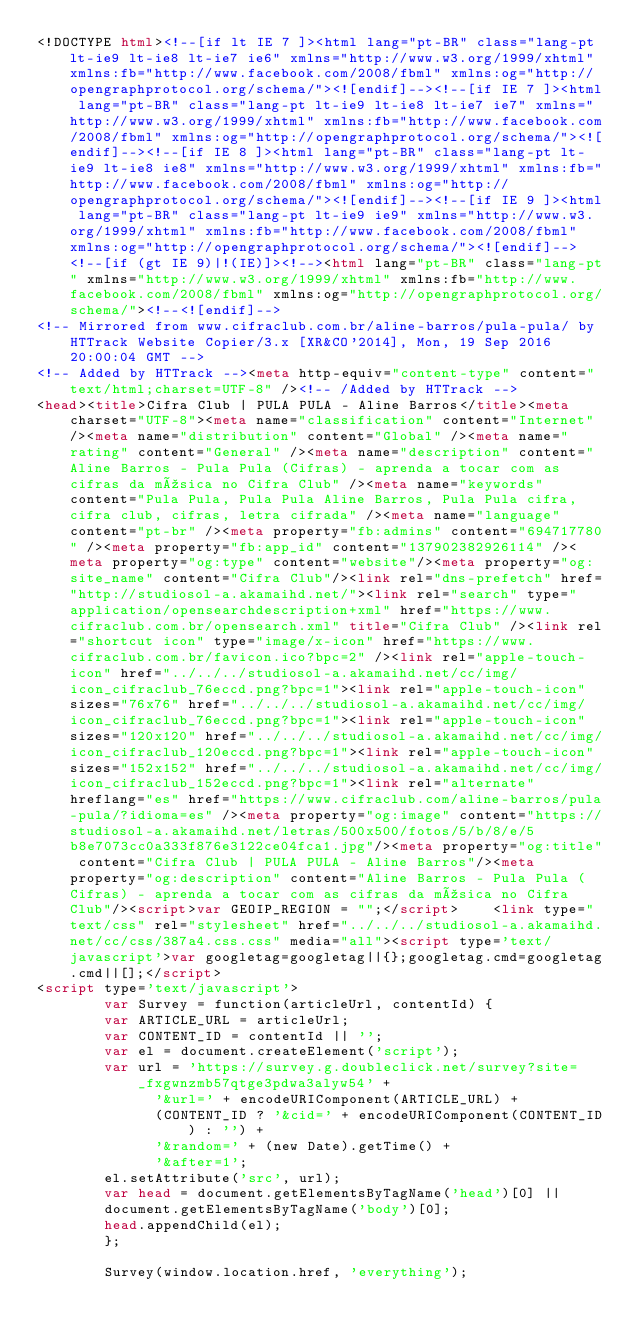<code> <loc_0><loc_0><loc_500><loc_500><_HTML_><!DOCTYPE html><!--[if lt IE 7 ]><html lang="pt-BR" class="lang-pt lt-ie9 lt-ie8 lt-ie7 ie6" xmlns="http://www.w3.org/1999/xhtml" xmlns:fb="http://www.facebook.com/2008/fbml" xmlns:og="http://opengraphprotocol.org/schema/"><![endif]--><!--[if IE 7 ]><html lang="pt-BR" class="lang-pt lt-ie9 lt-ie8 lt-ie7 ie7" xmlns="http://www.w3.org/1999/xhtml" xmlns:fb="http://www.facebook.com/2008/fbml" xmlns:og="http://opengraphprotocol.org/schema/"><![endif]--><!--[if IE 8 ]><html lang="pt-BR" class="lang-pt lt-ie9 lt-ie8 ie8" xmlns="http://www.w3.org/1999/xhtml" xmlns:fb="http://www.facebook.com/2008/fbml" xmlns:og="http://opengraphprotocol.org/schema/"><![endif]--><!--[if IE 9 ]><html lang="pt-BR" class="lang-pt lt-ie9 ie9" xmlns="http://www.w3.org/1999/xhtml" xmlns:fb="http://www.facebook.com/2008/fbml" xmlns:og="http://opengraphprotocol.org/schema/"><![endif]--><!--[if (gt IE 9)|!(IE)]><!--><html lang="pt-BR" class="lang-pt" xmlns="http://www.w3.org/1999/xhtml" xmlns:fb="http://www.facebook.com/2008/fbml" xmlns:og="http://opengraphprotocol.org/schema/"><!--<![endif]-->
<!-- Mirrored from www.cifraclub.com.br/aline-barros/pula-pula/ by HTTrack Website Copier/3.x [XR&CO'2014], Mon, 19 Sep 2016 20:00:04 GMT -->
<!-- Added by HTTrack --><meta http-equiv="content-type" content="text/html;charset=UTF-8" /><!-- /Added by HTTrack -->
<head><title>Cifra Club | PULA PULA - Aline Barros</title><meta charset="UTF-8"><meta name="classification" content="Internet" /><meta name="distribution" content="Global" /><meta name="rating" content="General" /><meta name="description" content="Aline Barros - Pula Pula (Cifras) - aprenda a tocar com as cifras da música no Cifra Club" /><meta name="keywords" content="Pula Pula, Pula Pula Aline Barros, Pula Pula cifra, cifra club, cifras, letra cifrada" /><meta name="language" content="pt-br" /><meta property="fb:admins" content="694717780" /><meta property="fb:app_id" content="137902382926114" /><meta property="og:type" content="website"/><meta property="og:site_name" content="Cifra Club"/><link rel="dns-prefetch" href="http://studiosol-a.akamaihd.net/"><link rel="search" type="application/opensearchdescription+xml" href="https://www.cifraclub.com.br/opensearch.xml" title="Cifra Club" /><link rel="shortcut icon" type="image/x-icon" href="https://www.cifraclub.com.br/favicon.ico?bpc=2" /><link rel="apple-touch-icon" href="../../../studiosol-a.akamaihd.net/cc/img/icon_cifraclub_76eccd.png?bpc=1"><link rel="apple-touch-icon" sizes="76x76" href="../../../studiosol-a.akamaihd.net/cc/img/icon_cifraclub_76eccd.png?bpc=1"><link rel="apple-touch-icon" sizes="120x120" href="../../../studiosol-a.akamaihd.net/cc/img/icon_cifraclub_120eccd.png?bpc=1"><link rel="apple-touch-icon" sizes="152x152" href="../../../studiosol-a.akamaihd.net/cc/img/icon_cifraclub_152eccd.png?bpc=1"><link rel="alternate" hreflang="es" href="https://www.cifraclub.com/aline-barros/pula-pula/?idioma=es" /><meta property="og:image" content="https://studiosol-a.akamaihd.net/letras/500x500/fotos/5/b/8/e/5b8e7073cc0a333f876e3122ce04fca1.jpg"/><meta property="og:title" content="Cifra Club | PULA PULA - Aline Barros"/><meta property="og:description" content="Aline Barros - Pula Pula (Cifras) - aprenda a tocar com as cifras da música no Cifra Club"/><script>var GEOIP_REGION = "";</script>    <link type="text/css" rel="stylesheet" href="../../../studiosol-a.akamaihd.net/cc/css/387a4.css.css" media="all"><script type='text/javascript'>var googletag=googletag||{};googletag.cmd=googletag.cmd||[];</script>
<script type='text/javascript'>
        var Survey = function(articleUrl, contentId) {
        var ARTICLE_URL = articleUrl;
        var CONTENT_ID = contentId || '';
        var el = document.createElement('script');
        var url = 'https://survey.g.doubleclick.net/survey?site=_fxgwnzmb57qtge3pdwa3alyw54' +
              '&url=' + encodeURIComponent(ARTICLE_URL) +
              (CONTENT_ID ? '&cid=' + encodeURIComponent(CONTENT_ID) : '') +
              '&random=' + (new Date).getTime() +
              '&after=1';
        el.setAttribute('src', url);
        var head = document.getElementsByTagName('head')[0] ||
        document.getElementsByTagName('body')[0];
        head.appendChild(el);
        };

        Survey(window.location.href, 'everything');</code> 